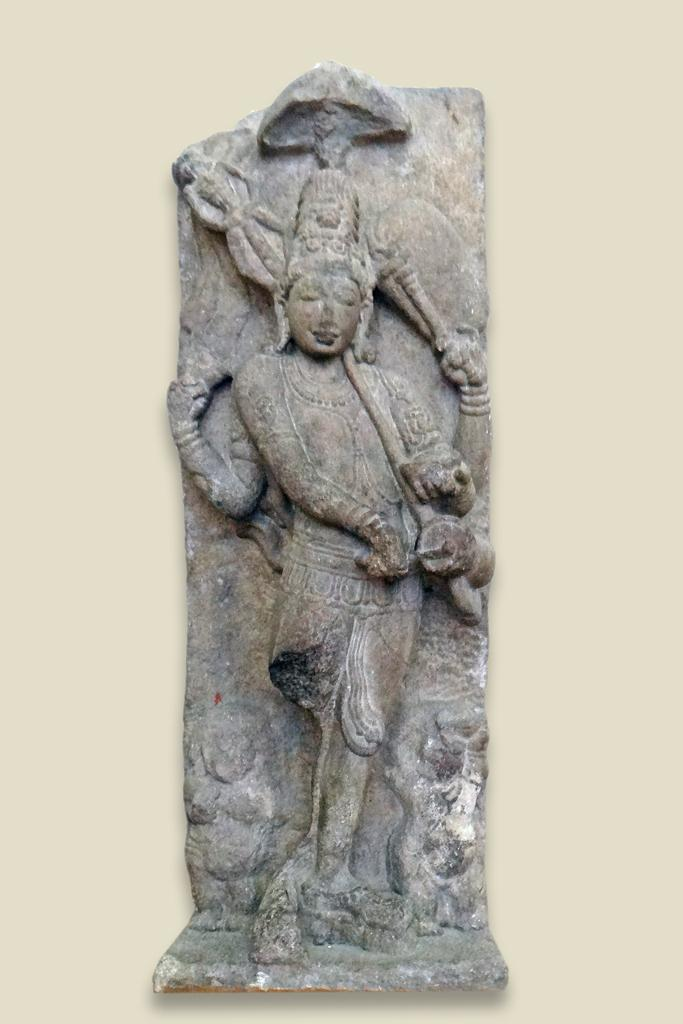What is the main subject of the image? There is a sculpture in the middle of the image. What can be seen in the background of the image? The background of the image is cream in color. What type of knife is being used to carve the bear in the image? There is no bear or knife present in the image; it features a sculpture and a cream-colored background. 